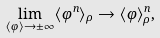Convert formula to latex. <formula><loc_0><loc_0><loc_500><loc_500>\lim _ { \langle \varphi \rangle \rightarrow \pm \infty } \langle \varphi ^ { n } \rangle _ { \rho } \to \langle \varphi \rangle _ { \rho } ^ { n } ,</formula> 